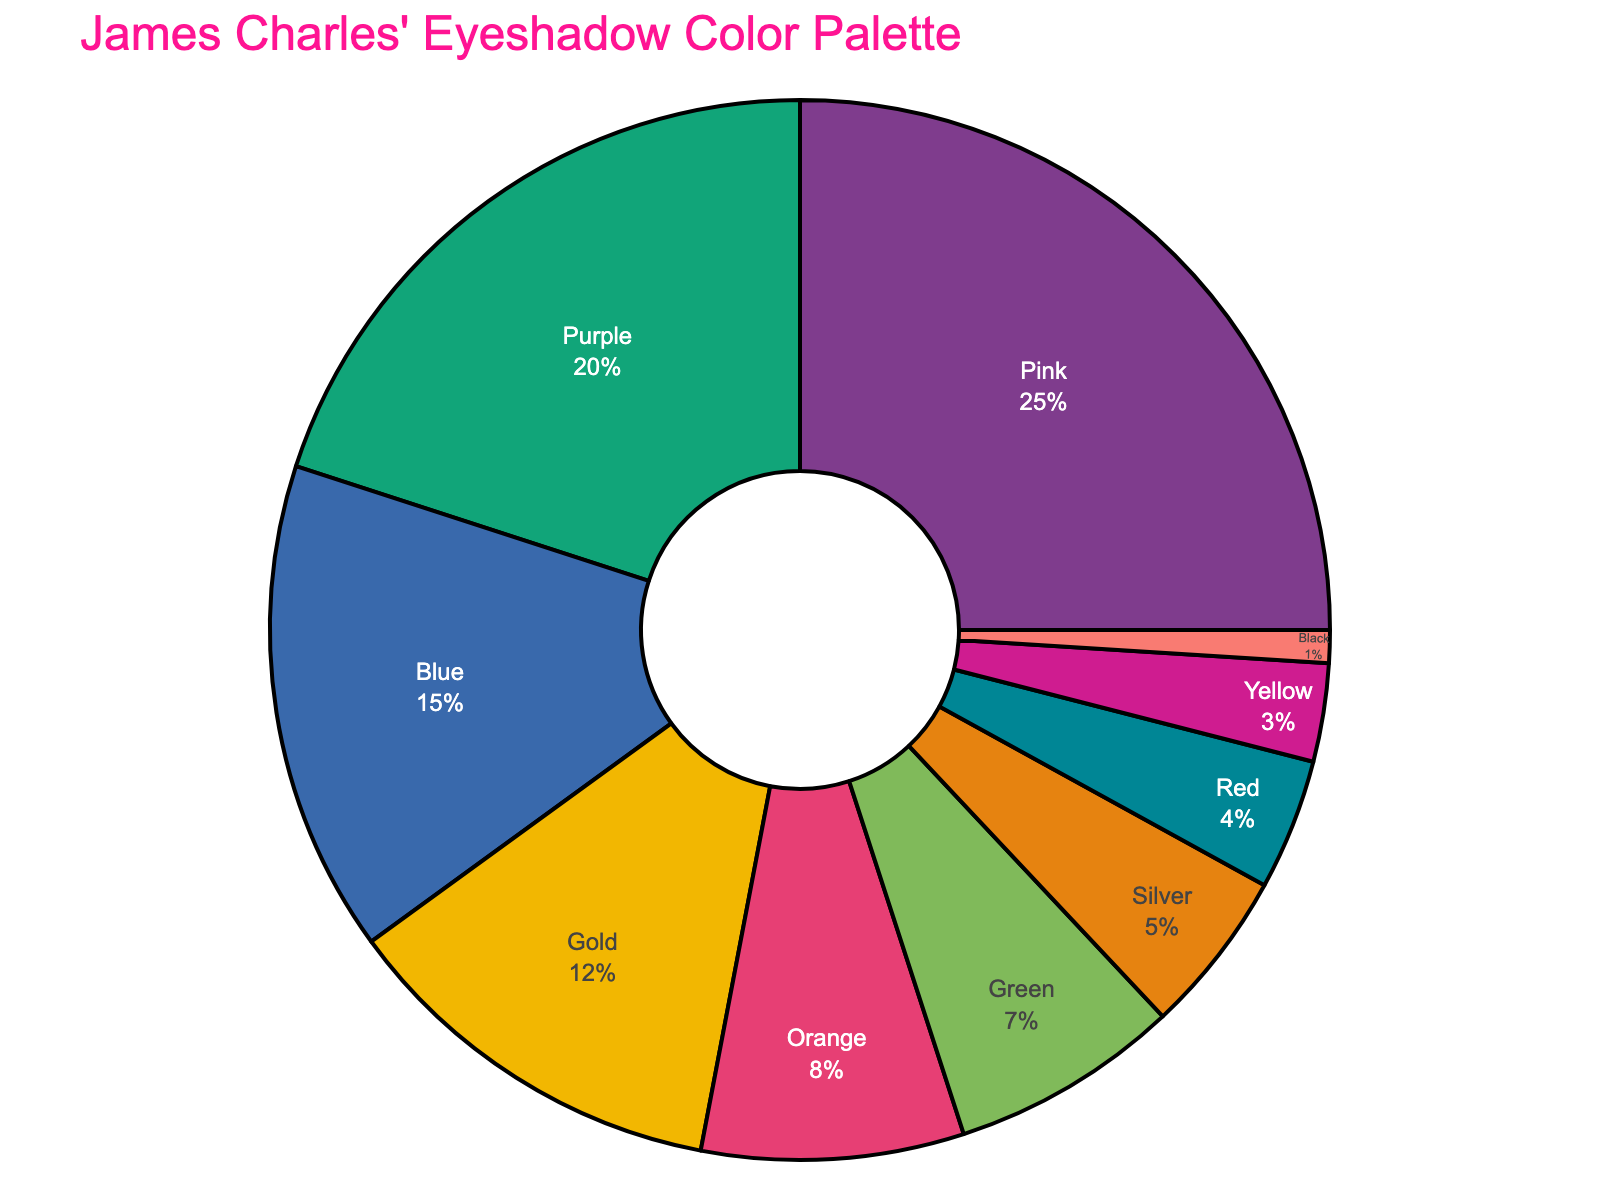Which eyeshadow color is used the most in James Charles' looks? The pie chart shows various colors with different proportions. The color with the largest slice represents the highest percentage. By observing, the Pink segment is the largest
Answer: Pink Which three eyeshadow colors have the smallest proportions? By examining the pie chart, the smallest slices correspond to the eyeshadow colors with the lowest percentages. The slices for Black, Yellow, and Red are the smallest
Answer: Black, Yellow, Red What is the total percentage of Pink, Purple, and Blue eyeshadow colors combined? Summing the percentages of Pink (25%), Purple (20%), and Blue (15%) gives the total percentage: 25 + 20 + 15
Answer: 60% Is the percentage of Gold eyeshadow higher or lower than the percentage of Blue eyeshadow? Comparing the proportions, the pie chart shows the percentage of Blue (15%) and Gold (12%). Since 15% is greater than 12%, Blue is higher than Gold
Answer: Lower Are there more colors with a percentage higher than 10% or lower than 10%? Count the slices in the pie chart with percentages higher than 10%: Pink (25%), Purple (20%), Blue (15%), Gold (12%) - 4 colors. Count the slices lower than 10%: Orange (8%), Green (7%), Silver (5%), Red (4%), Yellow (3%), Black (1%) - 6 colors. Therefore, more colors are lower than 10%
Answer: Lower than 10% What is the difference in percentage between the highest and the lowest used eyeshadow colors? The highest used color is Pink (25%). The lowest is Black (1%). Subtracting them: 25 - 1
Answer: 24% How much more popular is the Pink eyeshadow compared to the Green eyeshadow? Pink’s proportion is 25% and Green’s is 7%. The difference: 25 - 7
Answer: 18% Which color is exactly 4% of the total used colors? By identifying the pie chart section labeled with 4%, it's noted as Red
Answer: Red What colors make up a quarter of the total usage? A quarter is 25%. Pink is exactly 25%, covering a quarter of the total usage
Answer: Pink Is there a higher total percentage of warm colors (Pink, Orange, Red, Yellow) or cool colors (Purple, Blue, Green, Silver)? Sum warm colors: Pink (25) + Orange (8) + Red (4) + Yellow (3) = 40%. Sum cool colors: Purple (20) + Blue (15) + Green (7) + Silver (5) = 47%. Cool colors have a higher total percentage
Answer: Cool colors 